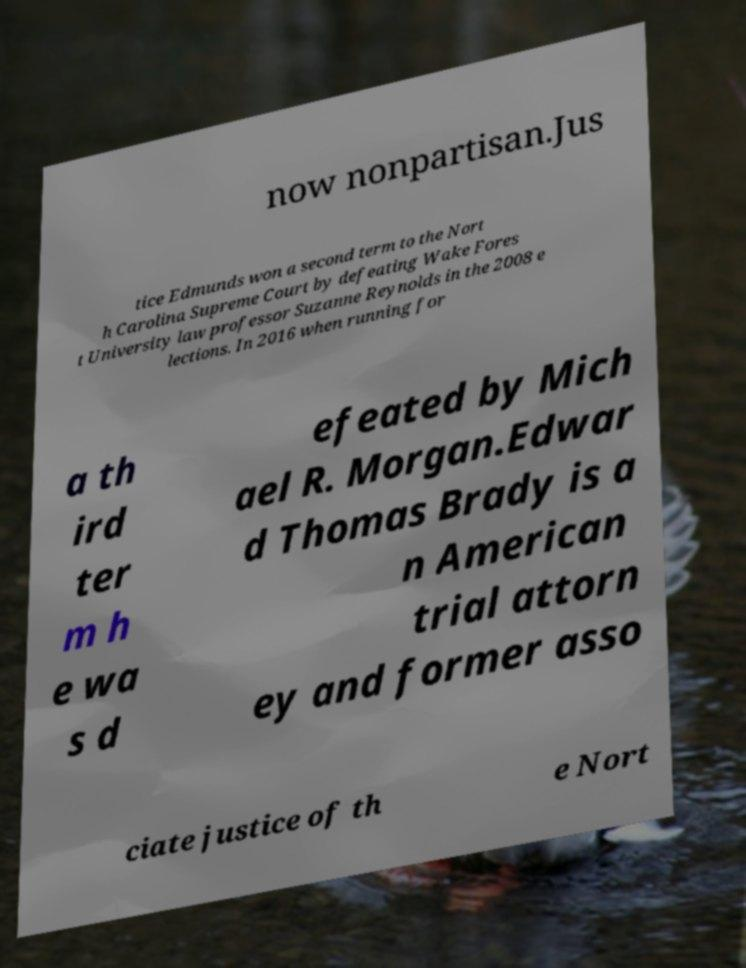I need the written content from this picture converted into text. Can you do that? now nonpartisan.Jus tice Edmunds won a second term to the Nort h Carolina Supreme Court by defeating Wake Fores t University law professor Suzanne Reynolds in the 2008 e lections. In 2016 when running for a th ird ter m h e wa s d efeated by Mich ael R. Morgan.Edwar d Thomas Brady is a n American trial attorn ey and former asso ciate justice of th e Nort 